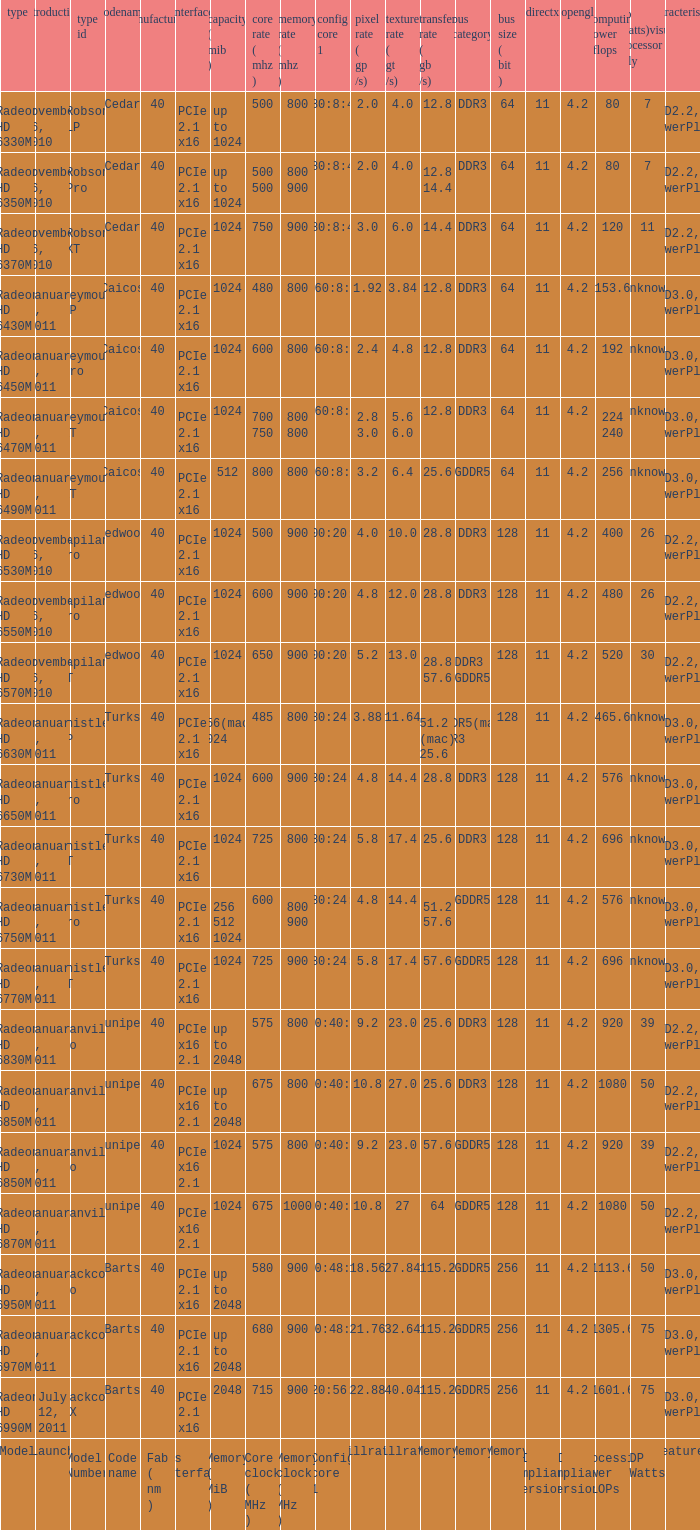What are all the code names for the radeon hd 6650m model? Turks. 